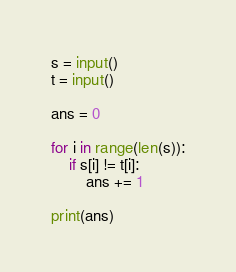<code> <loc_0><loc_0><loc_500><loc_500><_Python_>s = input()
t = input()

ans = 0

for i in range(len(s)):
    if s[i] != t[i]:
        ans += 1

print(ans)
</code> 